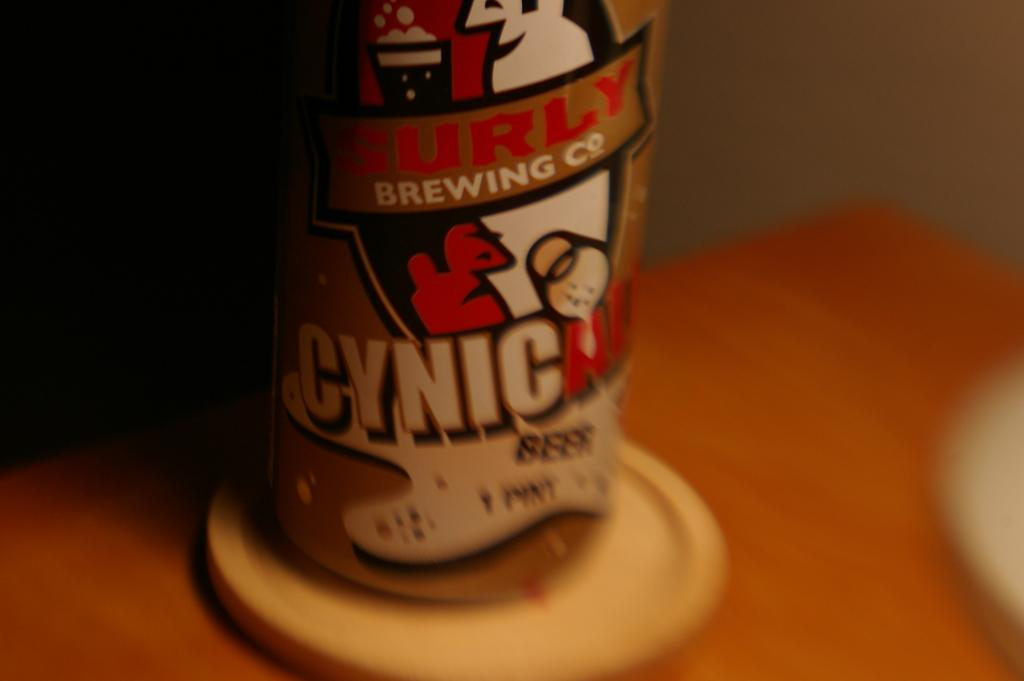<image>
Create a compact narrative representing the image presented. a cynic can of liquid with a man on the cover 